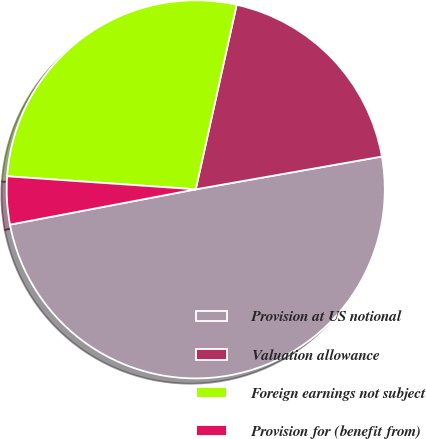Convert chart to OTSL. <chart><loc_0><loc_0><loc_500><loc_500><pie_chart><fcel>Provision at US notional<fcel>Valuation allowance<fcel>Foreign earnings not subject<fcel>Provision for (benefit from)<nl><fcel>49.78%<fcel>18.75%<fcel>27.37%<fcel>4.09%<nl></chart> 